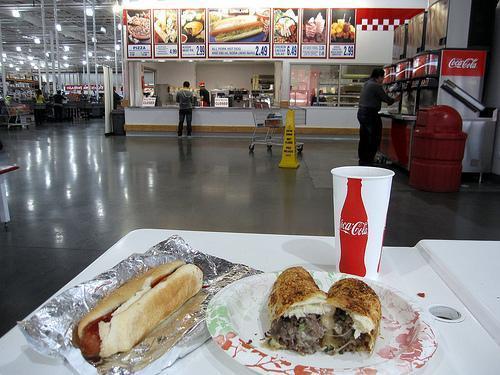How many hot dogs are there?
Give a very brief answer. 1. 